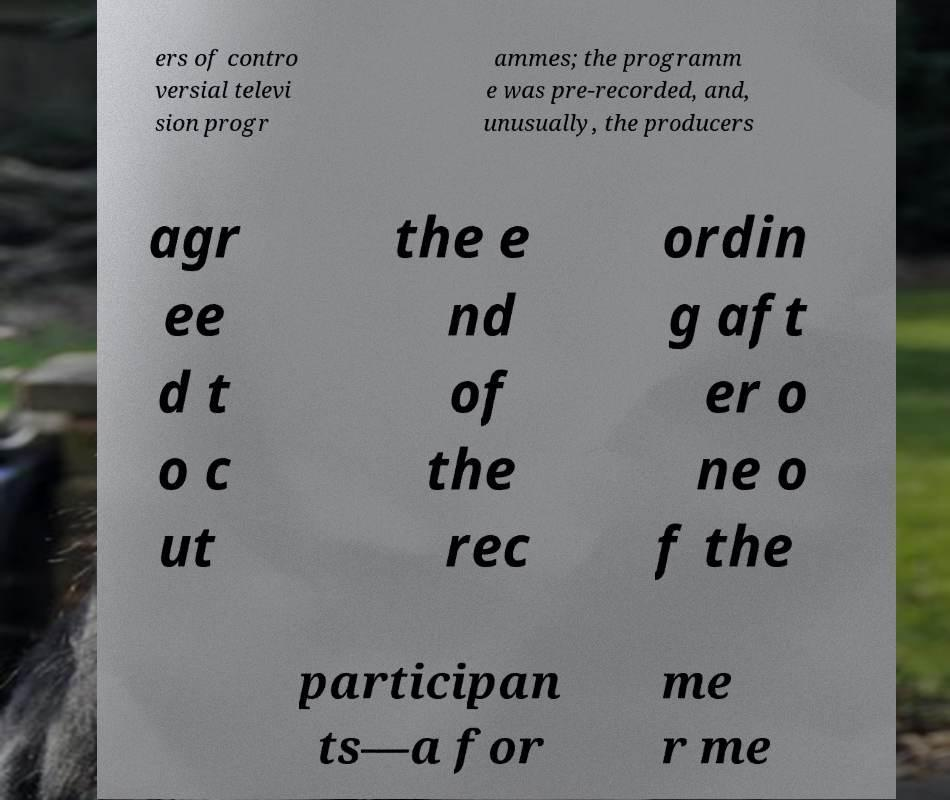Please read and relay the text visible in this image. What does it say? ers of contro versial televi sion progr ammes; the programm e was pre-recorded, and, unusually, the producers agr ee d t o c ut the e nd of the rec ordin g aft er o ne o f the participan ts—a for me r me 